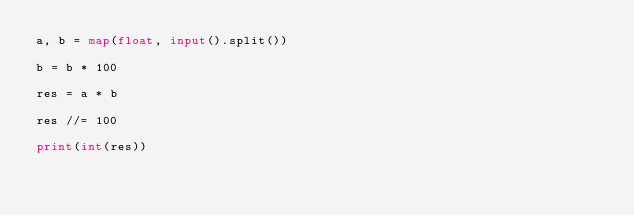<code> <loc_0><loc_0><loc_500><loc_500><_Python_>a, b = map(float, input().split())

b = b * 100

res = a * b

res //= 100

print(int(res))</code> 